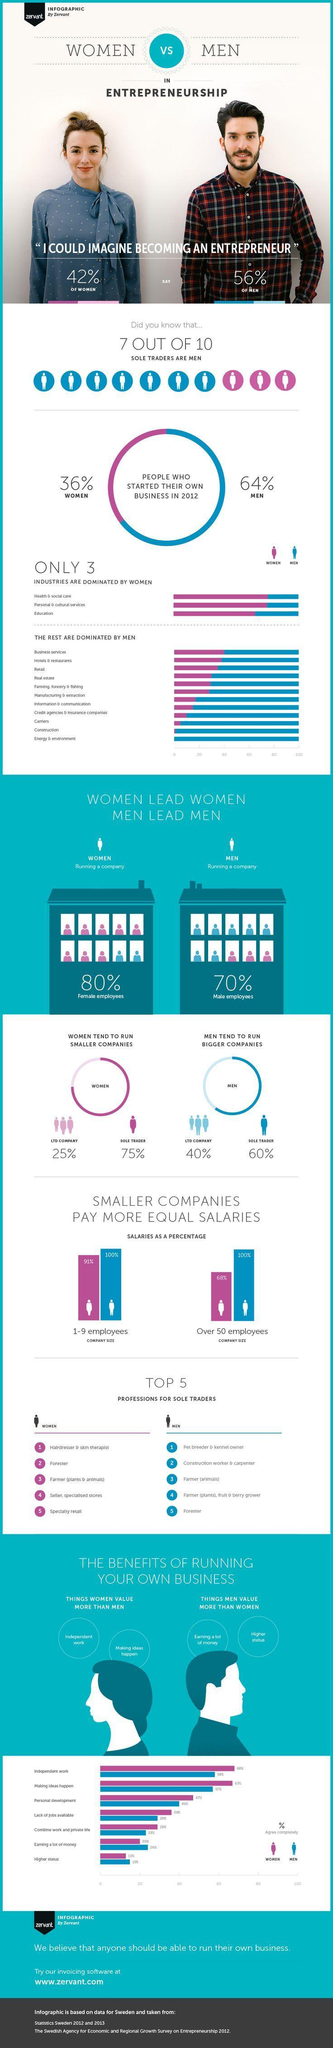How many industries are dominated by men?
Answer the question with a short phrase. 11 What percentage of women started their own business in 2012? 42% How many industries are not dominated by women? 11 Which all industries not dominated by men? Health & social care, Personal & cultural services, Education Out of 10, how many sole traders are not men? 3 What percentage of men started their own business in 2012? 56% 